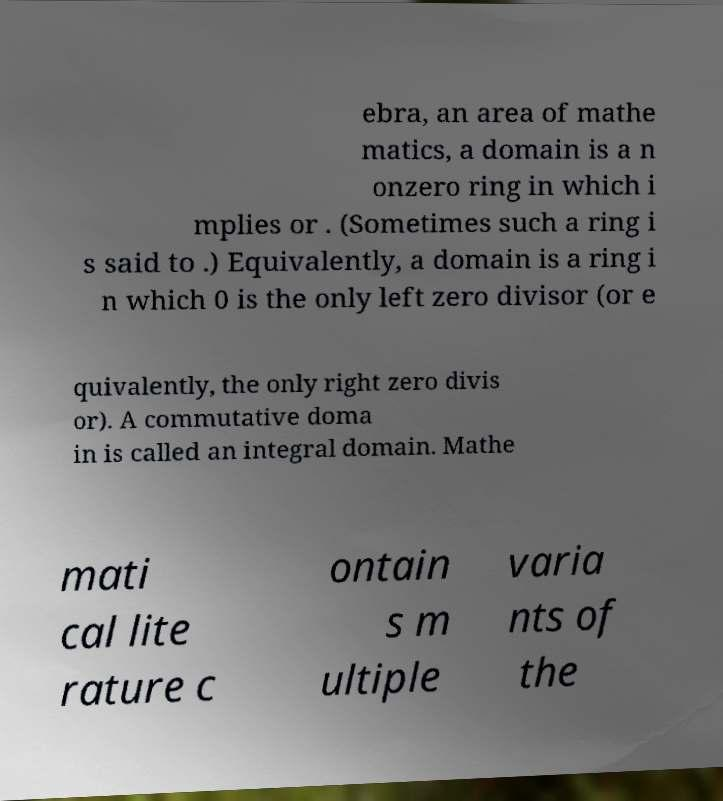Could you extract and type out the text from this image? ebra, an area of mathe matics, a domain is a n onzero ring in which i mplies or . (Sometimes such a ring i s said to .) Equivalently, a domain is a ring i n which 0 is the only left zero divisor (or e quivalently, the only right zero divis or). A commutative doma in is called an integral domain. Mathe mati cal lite rature c ontain s m ultiple varia nts of the 